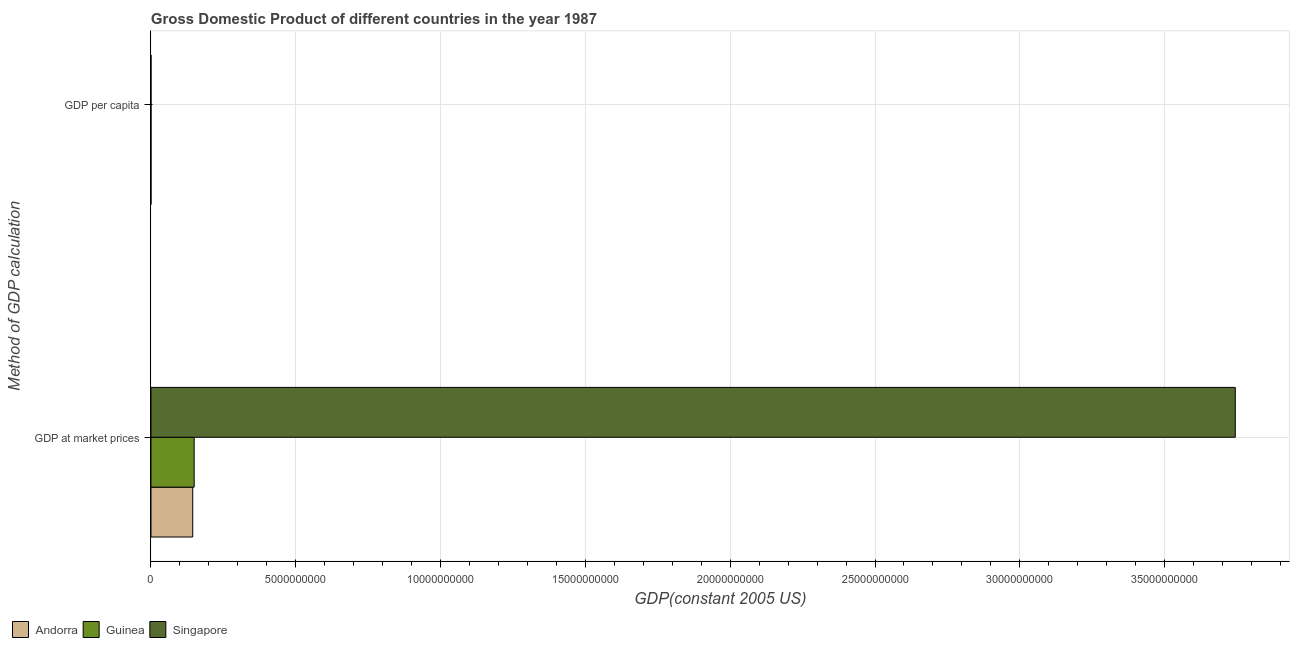How many different coloured bars are there?
Provide a short and direct response. 3. Are the number of bars on each tick of the Y-axis equal?
Give a very brief answer. Yes. How many bars are there on the 2nd tick from the top?
Your answer should be very brief. 3. What is the label of the 2nd group of bars from the top?
Offer a very short reply. GDP at market prices. What is the gdp at market prices in Singapore?
Provide a succinct answer. 3.74e+1. Across all countries, what is the maximum gdp per capita?
Provide a short and direct response. 2.98e+04. Across all countries, what is the minimum gdp per capita?
Make the answer very short. 277.55. In which country was the gdp per capita maximum?
Ensure brevity in your answer.  Andorra. In which country was the gdp at market prices minimum?
Give a very brief answer. Andorra. What is the total gdp at market prices in the graph?
Keep it short and to the point. 4.04e+1. What is the difference between the gdp at market prices in Singapore and that in Andorra?
Your response must be concise. 3.60e+1. What is the difference between the gdp per capita in Singapore and the gdp at market prices in Andorra?
Your answer should be very brief. -1.44e+09. What is the average gdp at market prices per country?
Make the answer very short. 1.35e+1. What is the difference between the gdp per capita and gdp at market prices in Andorra?
Make the answer very short. -1.44e+09. What is the ratio of the gdp per capita in Guinea to that in Singapore?
Ensure brevity in your answer.  0.02. What does the 3rd bar from the top in GDP at market prices represents?
Your answer should be very brief. Andorra. What does the 1st bar from the bottom in GDP per capita represents?
Provide a succinct answer. Andorra. How many bars are there?
Provide a short and direct response. 6. Are all the bars in the graph horizontal?
Provide a short and direct response. Yes. How many countries are there in the graph?
Ensure brevity in your answer.  3. Are the values on the major ticks of X-axis written in scientific E-notation?
Keep it short and to the point. No. Does the graph contain any zero values?
Ensure brevity in your answer.  No. How many legend labels are there?
Offer a terse response. 3. What is the title of the graph?
Ensure brevity in your answer.  Gross Domestic Product of different countries in the year 1987. Does "Iraq" appear as one of the legend labels in the graph?
Provide a short and direct response. No. What is the label or title of the X-axis?
Give a very brief answer. GDP(constant 2005 US). What is the label or title of the Y-axis?
Give a very brief answer. Method of GDP calculation. What is the GDP(constant 2005 US) in Andorra in GDP at market prices?
Offer a very short reply. 1.44e+09. What is the GDP(constant 2005 US) of Guinea in GDP at market prices?
Offer a terse response. 1.49e+09. What is the GDP(constant 2005 US) of Singapore in GDP at market prices?
Provide a short and direct response. 3.74e+1. What is the GDP(constant 2005 US) of Andorra in GDP per capita?
Ensure brevity in your answer.  2.98e+04. What is the GDP(constant 2005 US) in Guinea in GDP per capita?
Offer a terse response. 277.55. What is the GDP(constant 2005 US) of Singapore in GDP per capita?
Keep it short and to the point. 1.35e+04. Across all Method of GDP calculation, what is the maximum GDP(constant 2005 US) of Andorra?
Provide a succinct answer. 1.44e+09. Across all Method of GDP calculation, what is the maximum GDP(constant 2005 US) of Guinea?
Provide a succinct answer. 1.49e+09. Across all Method of GDP calculation, what is the maximum GDP(constant 2005 US) in Singapore?
Offer a very short reply. 3.74e+1. Across all Method of GDP calculation, what is the minimum GDP(constant 2005 US) in Andorra?
Your response must be concise. 2.98e+04. Across all Method of GDP calculation, what is the minimum GDP(constant 2005 US) of Guinea?
Make the answer very short. 277.55. Across all Method of GDP calculation, what is the minimum GDP(constant 2005 US) of Singapore?
Give a very brief answer. 1.35e+04. What is the total GDP(constant 2005 US) in Andorra in the graph?
Provide a short and direct response. 1.44e+09. What is the total GDP(constant 2005 US) of Guinea in the graph?
Provide a succinct answer. 1.49e+09. What is the total GDP(constant 2005 US) of Singapore in the graph?
Provide a succinct answer. 3.74e+1. What is the difference between the GDP(constant 2005 US) in Andorra in GDP at market prices and that in GDP per capita?
Offer a very short reply. 1.44e+09. What is the difference between the GDP(constant 2005 US) in Guinea in GDP at market prices and that in GDP per capita?
Your answer should be compact. 1.49e+09. What is the difference between the GDP(constant 2005 US) of Singapore in GDP at market prices and that in GDP per capita?
Provide a succinct answer. 3.74e+1. What is the difference between the GDP(constant 2005 US) in Andorra in GDP at market prices and the GDP(constant 2005 US) in Guinea in GDP per capita?
Your answer should be compact. 1.44e+09. What is the difference between the GDP(constant 2005 US) in Andorra in GDP at market prices and the GDP(constant 2005 US) in Singapore in GDP per capita?
Offer a very short reply. 1.44e+09. What is the difference between the GDP(constant 2005 US) in Guinea in GDP at market prices and the GDP(constant 2005 US) in Singapore in GDP per capita?
Your answer should be very brief. 1.49e+09. What is the average GDP(constant 2005 US) of Andorra per Method of GDP calculation?
Provide a succinct answer. 7.21e+08. What is the average GDP(constant 2005 US) in Guinea per Method of GDP calculation?
Your answer should be very brief. 7.46e+08. What is the average GDP(constant 2005 US) in Singapore per Method of GDP calculation?
Provide a succinct answer. 1.87e+1. What is the difference between the GDP(constant 2005 US) in Andorra and GDP(constant 2005 US) in Guinea in GDP at market prices?
Your response must be concise. -4.98e+07. What is the difference between the GDP(constant 2005 US) in Andorra and GDP(constant 2005 US) in Singapore in GDP at market prices?
Provide a succinct answer. -3.60e+1. What is the difference between the GDP(constant 2005 US) of Guinea and GDP(constant 2005 US) of Singapore in GDP at market prices?
Keep it short and to the point. -3.59e+1. What is the difference between the GDP(constant 2005 US) of Andorra and GDP(constant 2005 US) of Guinea in GDP per capita?
Offer a terse response. 2.95e+04. What is the difference between the GDP(constant 2005 US) of Andorra and GDP(constant 2005 US) of Singapore in GDP per capita?
Your answer should be very brief. 1.63e+04. What is the difference between the GDP(constant 2005 US) of Guinea and GDP(constant 2005 US) of Singapore in GDP per capita?
Your answer should be compact. -1.32e+04. What is the ratio of the GDP(constant 2005 US) of Andorra in GDP at market prices to that in GDP per capita?
Provide a succinct answer. 4.85e+04. What is the ratio of the GDP(constant 2005 US) of Guinea in GDP at market prices to that in GDP per capita?
Provide a succinct answer. 5.38e+06. What is the ratio of the GDP(constant 2005 US) in Singapore in GDP at market prices to that in GDP per capita?
Give a very brief answer. 2.77e+06. What is the difference between the highest and the second highest GDP(constant 2005 US) of Andorra?
Offer a terse response. 1.44e+09. What is the difference between the highest and the second highest GDP(constant 2005 US) of Guinea?
Offer a very short reply. 1.49e+09. What is the difference between the highest and the second highest GDP(constant 2005 US) of Singapore?
Your answer should be compact. 3.74e+1. What is the difference between the highest and the lowest GDP(constant 2005 US) in Andorra?
Provide a succinct answer. 1.44e+09. What is the difference between the highest and the lowest GDP(constant 2005 US) of Guinea?
Provide a succinct answer. 1.49e+09. What is the difference between the highest and the lowest GDP(constant 2005 US) of Singapore?
Your response must be concise. 3.74e+1. 